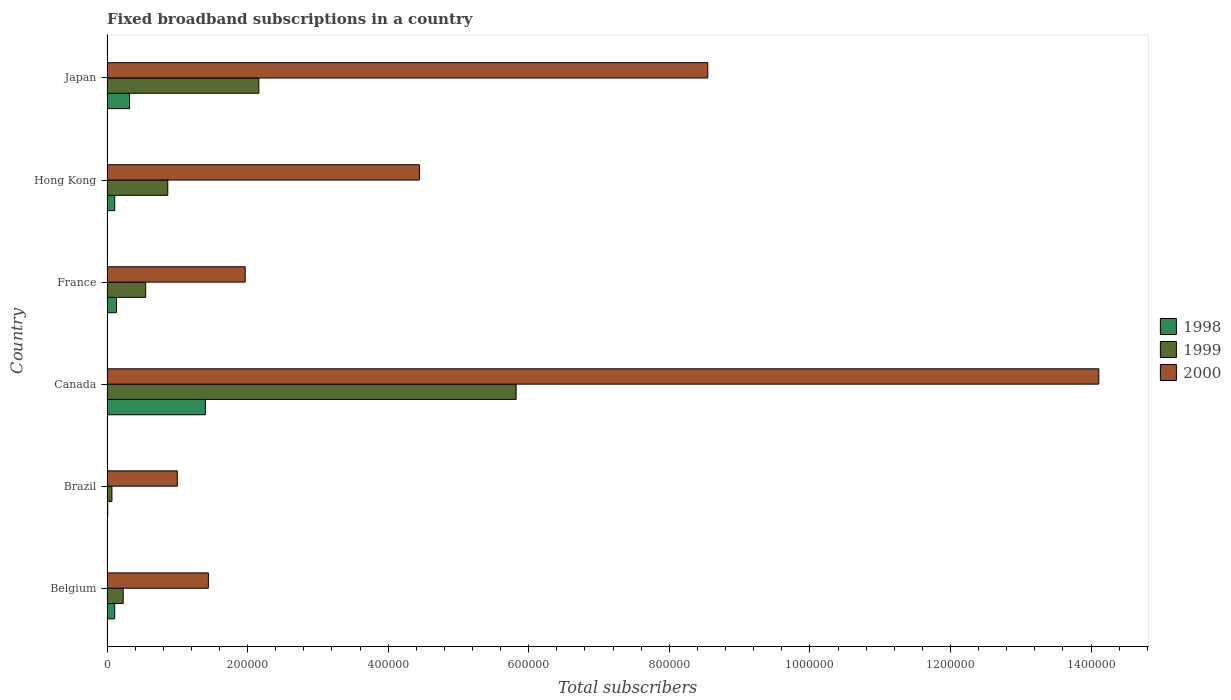Are the number of bars on each tick of the Y-axis equal?
Offer a very short reply. Yes. What is the number of broadband subscriptions in 1998 in Japan?
Your response must be concise. 3.20e+04. Across all countries, what is the maximum number of broadband subscriptions in 1999?
Your answer should be very brief. 5.82e+05. In which country was the number of broadband subscriptions in 2000 maximum?
Offer a terse response. Canada. In which country was the number of broadband subscriptions in 2000 minimum?
Your answer should be compact. Brazil. What is the total number of broadband subscriptions in 2000 in the graph?
Your answer should be compact. 3.15e+06. What is the difference between the number of broadband subscriptions in 1998 in Brazil and that in France?
Keep it short and to the point. -1.25e+04. What is the difference between the number of broadband subscriptions in 2000 in France and the number of broadband subscriptions in 1999 in Belgium?
Your answer should be compact. 1.74e+05. What is the average number of broadband subscriptions in 1999 per country?
Give a very brief answer. 1.62e+05. What is the difference between the number of broadband subscriptions in 2000 and number of broadband subscriptions in 1999 in Hong Kong?
Keep it short and to the point. 3.58e+05. In how many countries, is the number of broadband subscriptions in 1999 greater than 960000 ?
Keep it short and to the point. 0. What is the ratio of the number of broadband subscriptions in 1998 in Canada to that in Hong Kong?
Keep it short and to the point. 12.73. Is the number of broadband subscriptions in 2000 in Canada less than that in Japan?
Your answer should be very brief. No. What is the difference between the highest and the second highest number of broadband subscriptions in 1999?
Provide a succinct answer. 3.66e+05. What is the difference between the highest and the lowest number of broadband subscriptions in 2000?
Keep it short and to the point. 1.31e+06. Is the sum of the number of broadband subscriptions in 2000 in Belgium and Canada greater than the maximum number of broadband subscriptions in 1999 across all countries?
Keep it short and to the point. Yes. What does the 3rd bar from the top in Canada represents?
Offer a very short reply. 1998. What does the 3rd bar from the bottom in Canada represents?
Provide a short and direct response. 2000. Are all the bars in the graph horizontal?
Ensure brevity in your answer.  Yes. How many countries are there in the graph?
Your answer should be very brief. 6. What is the difference between two consecutive major ticks on the X-axis?
Keep it short and to the point. 2.00e+05. Are the values on the major ticks of X-axis written in scientific E-notation?
Ensure brevity in your answer.  No. Does the graph contain any zero values?
Your answer should be very brief. No. How many legend labels are there?
Your answer should be very brief. 3. How are the legend labels stacked?
Offer a very short reply. Vertical. What is the title of the graph?
Offer a terse response. Fixed broadband subscriptions in a country. What is the label or title of the X-axis?
Provide a short and direct response. Total subscribers. What is the Total subscribers of 1998 in Belgium?
Your response must be concise. 1.09e+04. What is the Total subscribers of 1999 in Belgium?
Provide a succinct answer. 2.30e+04. What is the Total subscribers of 2000 in Belgium?
Your response must be concise. 1.44e+05. What is the Total subscribers in 1998 in Brazil?
Provide a succinct answer. 1000. What is the Total subscribers of 1999 in Brazil?
Ensure brevity in your answer.  7000. What is the Total subscribers of 2000 in Brazil?
Give a very brief answer. 1.00e+05. What is the Total subscribers of 1999 in Canada?
Your answer should be very brief. 5.82e+05. What is the Total subscribers of 2000 in Canada?
Provide a short and direct response. 1.41e+06. What is the Total subscribers in 1998 in France?
Provide a short and direct response. 1.35e+04. What is the Total subscribers of 1999 in France?
Ensure brevity in your answer.  5.50e+04. What is the Total subscribers of 2000 in France?
Offer a very short reply. 1.97e+05. What is the Total subscribers of 1998 in Hong Kong?
Provide a short and direct response. 1.10e+04. What is the Total subscribers of 1999 in Hong Kong?
Give a very brief answer. 8.65e+04. What is the Total subscribers in 2000 in Hong Kong?
Your answer should be very brief. 4.44e+05. What is the Total subscribers of 1998 in Japan?
Provide a short and direct response. 3.20e+04. What is the Total subscribers of 1999 in Japan?
Your answer should be compact. 2.16e+05. What is the Total subscribers of 2000 in Japan?
Your answer should be compact. 8.55e+05. Across all countries, what is the maximum Total subscribers of 1999?
Your answer should be very brief. 5.82e+05. Across all countries, what is the maximum Total subscribers in 2000?
Ensure brevity in your answer.  1.41e+06. Across all countries, what is the minimum Total subscribers in 1999?
Your answer should be very brief. 7000. Across all countries, what is the minimum Total subscribers of 2000?
Offer a terse response. 1.00e+05. What is the total Total subscribers in 1998 in the graph?
Offer a very short reply. 2.08e+05. What is the total Total subscribers in 1999 in the graph?
Your answer should be very brief. 9.69e+05. What is the total Total subscribers in 2000 in the graph?
Your response must be concise. 3.15e+06. What is the difference between the Total subscribers of 1998 in Belgium and that in Brazil?
Make the answer very short. 9924. What is the difference between the Total subscribers in 1999 in Belgium and that in Brazil?
Give a very brief answer. 1.60e+04. What is the difference between the Total subscribers in 2000 in Belgium and that in Brazil?
Offer a very short reply. 4.42e+04. What is the difference between the Total subscribers of 1998 in Belgium and that in Canada?
Give a very brief answer. -1.29e+05. What is the difference between the Total subscribers of 1999 in Belgium and that in Canada?
Provide a short and direct response. -5.59e+05. What is the difference between the Total subscribers of 2000 in Belgium and that in Canada?
Offer a terse response. -1.27e+06. What is the difference between the Total subscribers in 1998 in Belgium and that in France?
Provide a short and direct response. -2540. What is the difference between the Total subscribers in 1999 in Belgium and that in France?
Provide a short and direct response. -3.20e+04. What is the difference between the Total subscribers in 2000 in Belgium and that in France?
Your answer should be compact. -5.24e+04. What is the difference between the Total subscribers in 1998 in Belgium and that in Hong Kong?
Make the answer very short. -76. What is the difference between the Total subscribers in 1999 in Belgium and that in Hong Kong?
Your response must be concise. -6.35e+04. What is the difference between the Total subscribers of 2000 in Belgium and that in Hong Kong?
Keep it short and to the point. -3.00e+05. What is the difference between the Total subscribers of 1998 in Belgium and that in Japan?
Make the answer very short. -2.11e+04. What is the difference between the Total subscribers in 1999 in Belgium and that in Japan?
Ensure brevity in your answer.  -1.93e+05. What is the difference between the Total subscribers in 2000 in Belgium and that in Japan?
Make the answer very short. -7.10e+05. What is the difference between the Total subscribers in 1998 in Brazil and that in Canada?
Offer a terse response. -1.39e+05. What is the difference between the Total subscribers in 1999 in Brazil and that in Canada?
Your answer should be compact. -5.75e+05. What is the difference between the Total subscribers of 2000 in Brazil and that in Canada?
Keep it short and to the point. -1.31e+06. What is the difference between the Total subscribers of 1998 in Brazil and that in France?
Ensure brevity in your answer.  -1.25e+04. What is the difference between the Total subscribers of 1999 in Brazil and that in France?
Give a very brief answer. -4.80e+04. What is the difference between the Total subscribers of 2000 in Brazil and that in France?
Your answer should be compact. -9.66e+04. What is the difference between the Total subscribers in 1999 in Brazil and that in Hong Kong?
Provide a succinct answer. -7.95e+04. What is the difference between the Total subscribers in 2000 in Brazil and that in Hong Kong?
Give a very brief answer. -3.44e+05. What is the difference between the Total subscribers of 1998 in Brazil and that in Japan?
Keep it short and to the point. -3.10e+04. What is the difference between the Total subscribers in 1999 in Brazil and that in Japan?
Your answer should be very brief. -2.09e+05. What is the difference between the Total subscribers of 2000 in Brazil and that in Japan?
Give a very brief answer. -7.55e+05. What is the difference between the Total subscribers of 1998 in Canada and that in France?
Provide a succinct answer. 1.27e+05. What is the difference between the Total subscribers of 1999 in Canada and that in France?
Provide a succinct answer. 5.27e+05. What is the difference between the Total subscribers of 2000 in Canada and that in France?
Offer a terse response. 1.21e+06. What is the difference between the Total subscribers in 1998 in Canada and that in Hong Kong?
Offer a terse response. 1.29e+05. What is the difference between the Total subscribers in 1999 in Canada and that in Hong Kong?
Provide a succinct answer. 4.96e+05. What is the difference between the Total subscribers in 2000 in Canada and that in Hong Kong?
Make the answer very short. 9.66e+05. What is the difference between the Total subscribers of 1998 in Canada and that in Japan?
Your response must be concise. 1.08e+05. What is the difference between the Total subscribers in 1999 in Canada and that in Japan?
Make the answer very short. 3.66e+05. What is the difference between the Total subscribers of 2000 in Canada and that in Japan?
Offer a terse response. 5.56e+05. What is the difference between the Total subscribers of 1998 in France and that in Hong Kong?
Your answer should be very brief. 2464. What is the difference between the Total subscribers in 1999 in France and that in Hong Kong?
Offer a terse response. -3.15e+04. What is the difference between the Total subscribers in 2000 in France and that in Hong Kong?
Keep it short and to the point. -2.48e+05. What is the difference between the Total subscribers of 1998 in France and that in Japan?
Your answer should be very brief. -1.85e+04. What is the difference between the Total subscribers in 1999 in France and that in Japan?
Your response must be concise. -1.61e+05. What is the difference between the Total subscribers of 2000 in France and that in Japan?
Give a very brief answer. -6.58e+05. What is the difference between the Total subscribers in 1998 in Hong Kong and that in Japan?
Make the answer very short. -2.10e+04. What is the difference between the Total subscribers in 1999 in Hong Kong and that in Japan?
Your response must be concise. -1.30e+05. What is the difference between the Total subscribers of 2000 in Hong Kong and that in Japan?
Offer a very short reply. -4.10e+05. What is the difference between the Total subscribers of 1998 in Belgium and the Total subscribers of 1999 in Brazil?
Give a very brief answer. 3924. What is the difference between the Total subscribers in 1998 in Belgium and the Total subscribers in 2000 in Brazil?
Offer a very short reply. -8.91e+04. What is the difference between the Total subscribers in 1999 in Belgium and the Total subscribers in 2000 in Brazil?
Give a very brief answer. -7.70e+04. What is the difference between the Total subscribers in 1998 in Belgium and the Total subscribers in 1999 in Canada?
Your answer should be compact. -5.71e+05. What is the difference between the Total subscribers of 1998 in Belgium and the Total subscribers of 2000 in Canada?
Keep it short and to the point. -1.40e+06. What is the difference between the Total subscribers in 1999 in Belgium and the Total subscribers in 2000 in Canada?
Provide a short and direct response. -1.39e+06. What is the difference between the Total subscribers in 1998 in Belgium and the Total subscribers in 1999 in France?
Provide a succinct answer. -4.41e+04. What is the difference between the Total subscribers in 1998 in Belgium and the Total subscribers in 2000 in France?
Offer a terse response. -1.86e+05. What is the difference between the Total subscribers in 1999 in Belgium and the Total subscribers in 2000 in France?
Offer a very short reply. -1.74e+05. What is the difference between the Total subscribers of 1998 in Belgium and the Total subscribers of 1999 in Hong Kong?
Your answer should be very brief. -7.55e+04. What is the difference between the Total subscribers of 1998 in Belgium and the Total subscribers of 2000 in Hong Kong?
Keep it short and to the point. -4.34e+05. What is the difference between the Total subscribers in 1999 in Belgium and the Total subscribers in 2000 in Hong Kong?
Offer a terse response. -4.21e+05. What is the difference between the Total subscribers in 1998 in Belgium and the Total subscribers in 1999 in Japan?
Ensure brevity in your answer.  -2.05e+05. What is the difference between the Total subscribers in 1998 in Belgium and the Total subscribers in 2000 in Japan?
Your response must be concise. -8.44e+05. What is the difference between the Total subscribers of 1999 in Belgium and the Total subscribers of 2000 in Japan?
Provide a succinct answer. -8.32e+05. What is the difference between the Total subscribers of 1998 in Brazil and the Total subscribers of 1999 in Canada?
Your response must be concise. -5.81e+05. What is the difference between the Total subscribers of 1998 in Brazil and the Total subscribers of 2000 in Canada?
Provide a succinct answer. -1.41e+06. What is the difference between the Total subscribers in 1999 in Brazil and the Total subscribers in 2000 in Canada?
Provide a short and direct response. -1.40e+06. What is the difference between the Total subscribers of 1998 in Brazil and the Total subscribers of 1999 in France?
Offer a terse response. -5.40e+04. What is the difference between the Total subscribers of 1998 in Brazil and the Total subscribers of 2000 in France?
Make the answer very short. -1.96e+05. What is the difference between the Total subscribers of 1999 in Brazil and the Total subscribers of 2000 in France?
Keep it short and to the point. -1.90e+05. What is the difference between the Total subscribers of 1998 in Brazil and the Total subscribers of 1999 in Hong Kong?
Your answer should be compact. -8.55e+04. What is the difference between the Total subscribers of 1998 in Brazil and the Total subscribers of 2000 in Hong Kong?
Provide a succinct answer. -4.43e+05. What is the difference between the Total subscribers in 1999 in Brazil and the Total subscribers in 2000 in Hong Kong?
Your response must be concise. -4.37e+05. What is the difference between the Total subscribers in 1998 in Brazil and the Total subscribers in 1999 in Japan?
Ensure brevity in your answer.  -2.15e+05. What is the difference between the Total subscribers of 1998 in Brazil and the Total subscribers of 2000 in Japan?
Offer a very short reply. -8.54e+05. What is the difference between the Total subscribers in 1999 in Brazil and the Total subscribers in 2000 in Japan?
Your answer should be very brief. -8.48e+05. What is the difference between the Total subscribers in 1998 in Canada and the Total subscribers in 1999 in France?
Make the answer very short. 8.50e+04. What is the difference between the Total subscribers of 1998 in Canada and the Total subscribers of 2000 in France?
Provide a short and direct response. -5.66e+04. What is the difference between the Total subscribers of 1999 in Canada and the Total subscribers of 2000 in France?
Keep it short and to the point. 3.85e+05. What is the difference between the Total subscribers in 1998 in Canada and the Total subscribers in 1999 in Hong Kong?
Provide a succinct answer. 5.35e+04. What is the difference between the Total subscribers of 1998 in Canada and the Total subscribers of 2000 in Hong Kong?
Give a very brief answer. -3.04e+05. What is the difference between the Total subscribers in 1999 in Canada and the Total subscribers in 2000 in Hong Kong?
Give a very brief answer. 1.38e+05. What is the difference between the Total subscribers in 1998 in Canada and the Total subscribers in 1999 in Japan?
Offer a terse response. -7.60e+04. What is the difference between the Total subscribers of 1998 in Canada and the Total subscribers of 2000 in Japan?
Your answer should be compact. -7.15e+05. What is the difference between the Total subscribers of 1999 in Canada and the Total subscribers of 2000 in Japan?
Ensure brevity in your answer.  -2.73e+05. What is the difference between the Total subscribers in 1998 in France and the Total subscribers in 1999 in Hong Kong?
Your answer should be very brief. -7.30e+04. What is the difference between the Total subscribers in 1998 in France and the Total subscribers in 2000 in Hong Kong?
Provide a succinct answer. -4.31e+05. What is the difference between the Total subscribers of 1999 in France and the Total subscribers of 2000 in Hong Kong?
Your answer should be very brief. -3.89e+05. What is the difference between the Total subscribers in 1998 in France and the Total subscribers in 1999 in Japan?
Offer a terse response. -2.03e+05. What is the difference between the Total subscribers in 1998 in France and the Total subscribers in 2000 in Japan?
Offer a terse response. -8.41e+05. What is the difference between the Total subscribers of 1999 in France and the Total subscribers of 2000 in Japan?
Give a very brief answer. -8.00e+05. What is the difference between the Total subscribers of 1998 in Hong Kong and the Total subscribers of 1999 in Japan?
Give a very brief answer. -2.05e+05. What is the difference between the Total subscribers of 1998 in Hong Kong and the Total subscribers of 2000 in Japan?
Provide a short and direct response. -8.44e+05. What is the difference between the Total subscribers in 1999 in Hong Kong and the Total subscribers in 2000 in Japan?
Ensure brevity in your answer.  -7.68e+05. What is the average Total subscribers in 1998 per country?
Ensure brevity in your answer.  3.47e+04. What is the average Total subscribers in 1999 per country?
Give a very brief answer. 1.62e+05. What is the average Total subscribers of 2000 per country?
Provide a short and direct response. 5.25e+05. What is the difference between the Total subscribers in 1998 and Total subscribers in 1999 in Belgium?
Offer a terse response. -1.21e+04. What is the difference between the Total subscribers in 1998 and Total subscribers in 2000 in Belgium?
Keep it short and to the point. -1.33e+05. What is the difference between the Total subscribers in 1999 and Total subscribers in 2000 in Belgium?
Give a very brief answer. -1.21e+05. What is the difference between the Total subscribers of 1998 and Total subscribers of 1999 in Brazil?
Keep it short and to the point. -6000. What is the difference between the Total subscribers of 1998 and Total subscribers of 2000 in Brazil?
Give a very brief answer. -9.90e+04. What is the difference between the Total subscribers of 1999 and Total subscribers of 2000 in Brazil?
Your response must be concise. -9.30e+04. What is the difference between the Total subscribers of 1998 and Total subscribers of 1999 in Canada?
Provide a short and direct response. -4.42e+05. What is the difference between the Total subscribers in 1998 and Total subscribers in 2000 in Canada?
Ensure brevity in your answer.  -1.27e+06. What is the difference between the Total subscribers of 1999 and Total subscribers of 2000 in Canada?
Your answer should be very brief. -8.29e+05. What is the difference between the Total subscribers of 1998 and Total subscribers of 1999 in France?
Offer a terse response. -4.15e+04. What is the difference between the Total subscribers of 1998 and Total subscribers of 2000 in France?
Ensure brevity in your answer.  -1.83e+05. What is the difference between the Total subscribers of 1999 and Total subscribers of 2000 in France?
Provide a short and direct response. -1.42e+05. What is the difference between the Total subscribers in 1998 and Total subscribers in 1999 in Hong Kong?
Offer a very short reply. -7.55e+04. What is the difference between the Total subscribers in 1998 and Total subscribers in 2000 in Hong Kong?
Provide a short and direct response. -4.33e+05. What is the difference between the Total subscribers in 1999 and Total subscribers in 2000 in Hong Kong?
Offer a very short reply. -3.58e+05. What is the difference between the Total subscribers in 1998 and Total subscribers in 1999 in Japan?
Make the answer very short. -1.84e+05. What is the difference between the Total subscribers of 1998 and Total subscribers of 2000 in Japan?
Your answer should be very brief. -8.23e+05. What is the difference between the Total subscribers of 1999 and Total subscribers of 2000 in Japan?
Offer a terse response. -6.39e+05. What is the ratio of the Total subscribers in 1998 in Belgium to that in Brazil?
Ensure brevity in your answer.  10.92. What is the ratio of the Total subscribers in 1999 in Belgium to that in Brazil?
Provide a succinct answer. 3.29. What is the ratio of the Total subscribers of 2000 in Belgium to that in Brazil?
Offer a terse response. 1.44. What is the ratio of the Total subscribers of 1998 in Belgium to that in Canada?
Ensure brevity in your answer.  0.08. What is the ratio of the Total subscribers in 1999 in Belgium to that in Canada?
Give a very brief answer. 0.04. What is the ratio of the Total subscribers in 2000 in Belgium to that in Canada?
Offer a terse response. 0.1. What is the ratio of the Total subscribers in 1998 in Belgium to that in France?
Provide a succinct answer. 0.81. What is the ratio of the Total subscribers of 1999 in Belgium to that in France?
Ensure brevity in your answer.  0.42. What is the ratio of the Total subscribers of 2000 in Belgium to that in France?
Provide a succinct answer. 0.73. What is the ratio of the Total subscribers of 1999 in Belgium to that in Hong Kong?
Offer a terse response. 0.27. What is the ratio of the Total subscribers of 2000 in Belgium to that in Hong Kong?
Provide a short and direct response. 0.32. What is the ratio of the Total subscribers in 1998 in Belgium to that in Japan?
Offer a terse response. 0.34. What is the ratio of the Total subscribers in 1999 in Belgium to that in Japan?
Offer a terse response. 0.11. What is the ratio of the Total subscribers in 2000 in Belgium to that in Japan?
Make the answer very short. 0.17. What is the ratio of the Total subscribers of 1998 in Brazil to that in Canada?
Keep it short and to the point. 0.01. What is the ratio of the Total subscribers in 1999 in Brazil to that in Canada?
Provide a succinct answer. 0.01. What is the ratio of the Total subscribers of 2000 in Brazil to that in Canada?
Provide a short and direct response. 0.07. What is the ratio of the Total subscribers in 1998 in Brazil to that in France?
Offer a very short reply. 0.07. What is the ratio of the Total subscribers of 1999 in Brazil to that in France?
Keep it short and to the point. 0.13. What is the ratio of the Total subscribers in 2000 in Brazil to that in France?
Provide a succinct answer. 0.51. What is the ratio of the Total subscribers in 1998 in Brazil to that in Hong Kong?
Your answer should be very brief. 0.09. What is the ratio of the Total subscribers in 1999 in Brazil to that in Hong Kong?
Your answer should be compact. 0.08. What is the ratio of the Total subscribers of 2000 in Brazil to that in Hong Kong?
Give a very brief answer. 0.23. What is the ratio of the Total subscribers of 1998 in Brazil to that in Japan?
Offer a very short reply. 0.03. What is the ratio of the Total subscribers in 1999 in Brazil to that in Japan?
Your answer should be compact. 0.03. What is the ratio of the Total subscribers in 2000 in Brazil to that in Japan?
Keep it short and to the point. 0.12. What is the ratio of the Total subscribers of 1998 in Canada to that in France?
Provide a succinct answer. 10.4. What is the ratio of the Total subscribers in 1999 in Canada to that in France?
Provide a short and direct response. 10.58. What is the ratio of the Total subscribers of 2000 in Canada to that in France?
Your answer should be compact. 7.18. What is the ratio of the Total subscribers in 1998 in Canada to that in Hong Kong?
Provide a succinct answer. 12.73. What is the ratio of the Total subscribers of 1999 in Canada to that in Hong Kong?
Make the answer very short. 6.73. What is the ratio of the Total subscribers of 2000 in Canada to that in Hong Kong?
Provide a short and direct response. 3.17. What is the ratio of the Total subscribers in 1998 in Canada to that in Japan?
Make the answer very short. 4.38. What is the ratio of the Total subscribers in 1999 in Canada to that in Japan?
Offer a terse response. 2.69. What is the ratio of the Total subscribers in 2000 in Canada to that in Japan?
Provide a short and direct response. 1.65. What is the ratio of the Total subscribers in 1998 in France to that in Hong Kong?
Your answer should be compact. 1.22. What is the ratio of the Total subscribers in 1999 in France to that in Hong Kong?
Offer a very short reply. 0.64. What is the ratio of the Total subscribers of 2000 in France to that in Hong Kong?
Offer a terse response. 0.44. What is the ratio of the Total subscribers of 1998 in France to that in Japan?
Make the answer very short. 0.42. What is the ratio of the Total subscribers in 1999 in France to that in Japan?
Your answer should be compact. 0.25. What is the ratio of the Total subscribers of 2000 in France to that in Japan?
Provide a short and direct response. 0.23. What is the ratio of the Total subscribers in 1998 in Hong Kong to that in Japan?
Give a very brief answer. 0.34. What is the ratio of the Total subscribers of 1999 in Hong Kong to that in Japan?
Provide a succinct answer. 0.4. What is the ratio of the Total subscribers of 2000 in Hong Kong to that in Japan?
Your response must be concise. 0.52. What is the difference between the highest and the second highest Total subscribers of 1998?
Your answer should be compact. 1.08e+05. What is the difference between the highest and the second highest Total subscribers of 1999?
Offer a very short reply. 3.66e+05. What is the difference between the highest and the second highest Total subscribers of 2000?
Provide a short and direct response. 5.56e+05. What is the difference between the highest and the lowest Total subscribers of 1998?
Your answer should be compact. 1.39e+05. What is the difference between the highest and the lowest Total subscribers of 1999?
Your response must be concise. 5.75e+05. What is the difference between the highest and the lowest Total subscribers of 2000?
Give a very brief answer. 1.31e+06. 